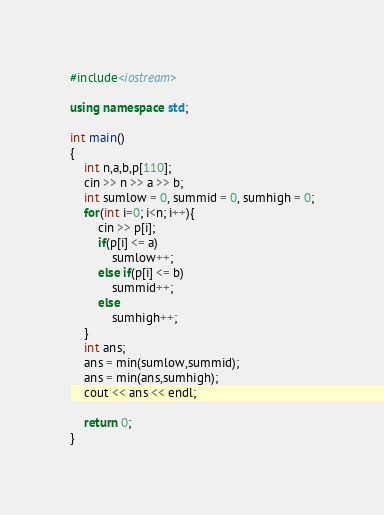Convert code to text. <code><loc_0><loc_0><loc_500><loc_500><_C++_>#include<iostream>

using namespace std;

int main()
{
	int n,a,b,p[110];
	cin >> n >> a >> b;
	int sumlow = 0, summid = 0, sumhigh = 0;
	for(int i=0; i<n; i++){
		cin >> p[i];
		if(p[i] <= a)
			sumlow++;
		else if(p[i] <= b)
			summid++;
		else
			sumhigh++;
	}
	int ans;
	ans = min(sumlow,summid);
	ans = min(ans,sumhigh);
	cout << ans << endl;
	
	return 0;
}
</code> 